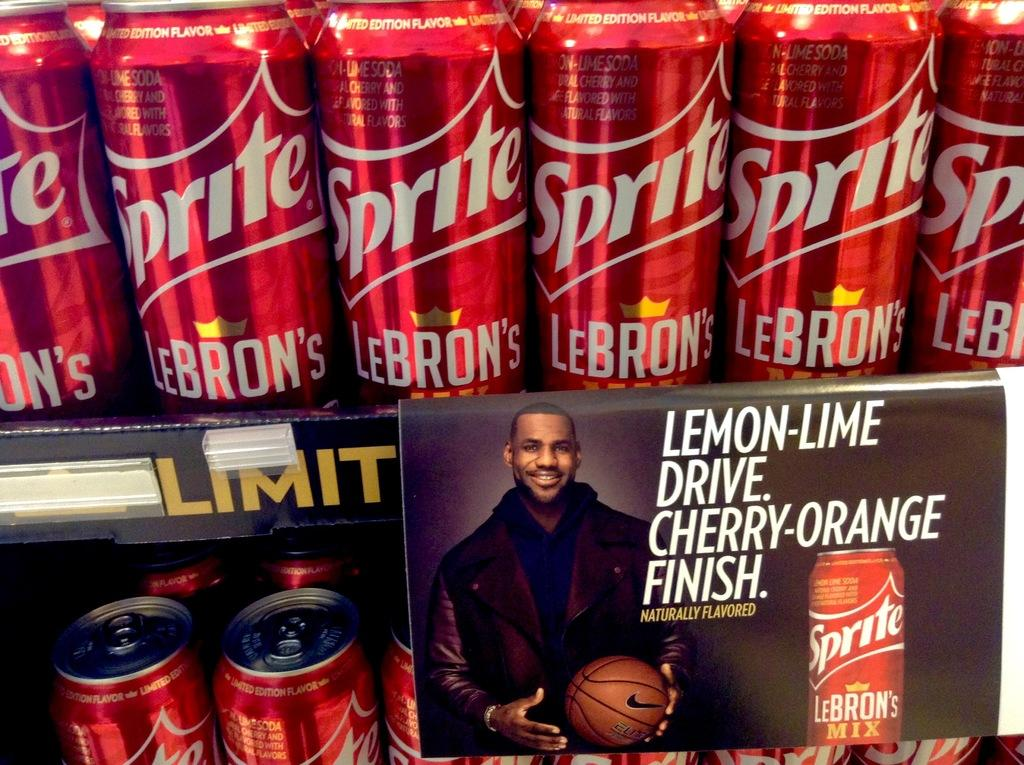<image>
Present a compact description of the photo's key features. Many cans of LeBron's Sprite line the shelves. 